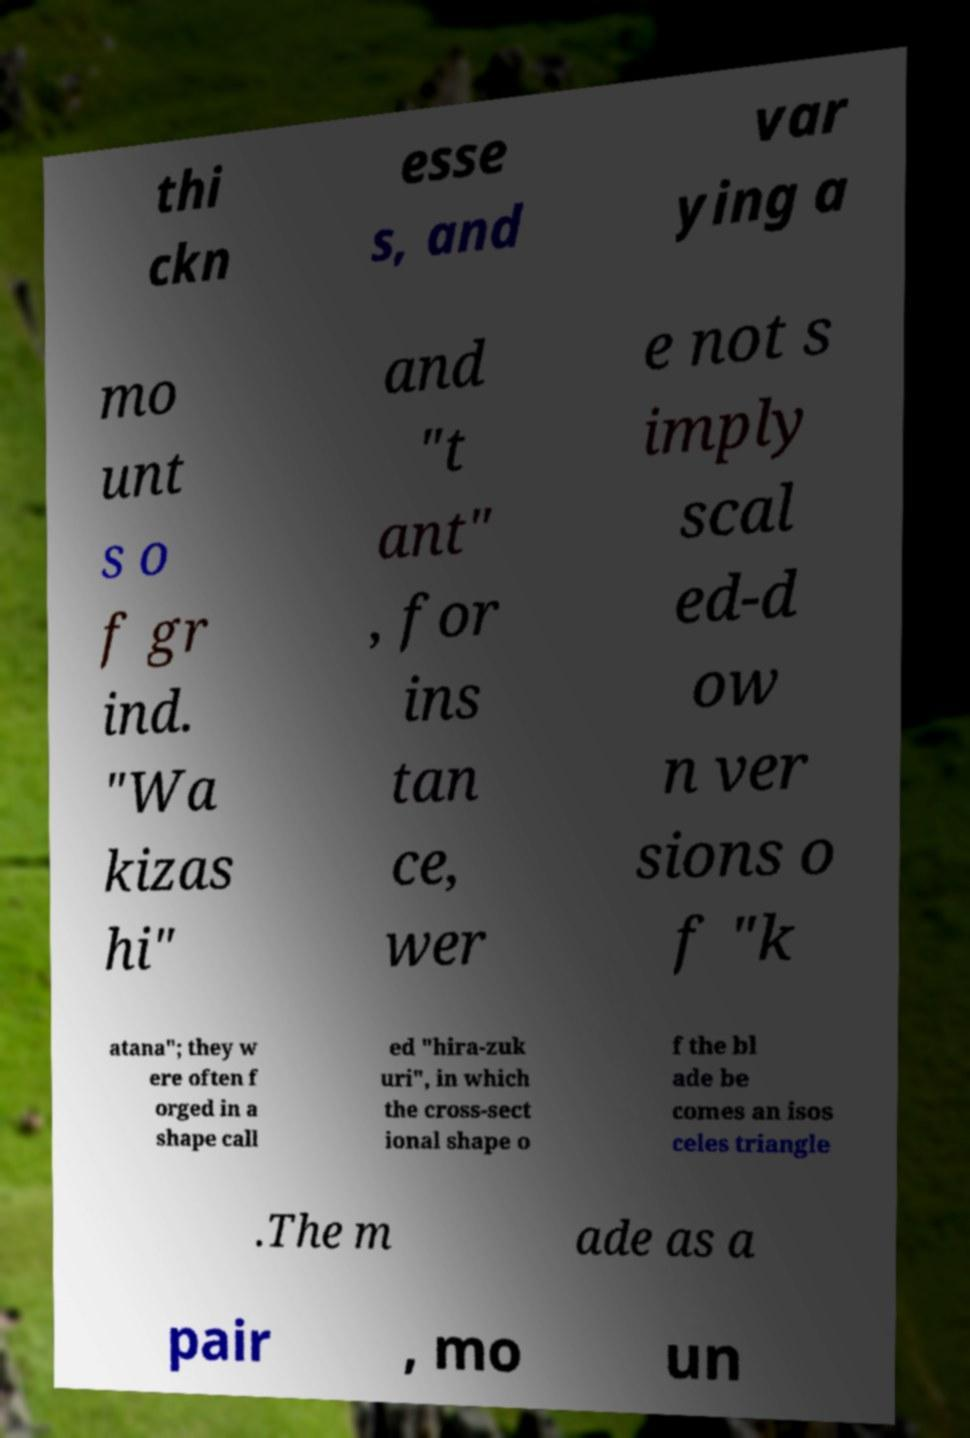Please read and relay the text visible in this image. What does it say? thi ckn esse s, and var ying a mo unt s o f gr ind. "Wa kizas hi" and "t ant" , for ins tan ce, wer e not s imply scal ed-d ow n ver sions o f "k atana"; they w ere often f orged in a shape call ed "hira-zuk uri", in which the cross-sect ional shape o f the bl ade be comes an isos celes triangle .The m ade as a pair , mo un 